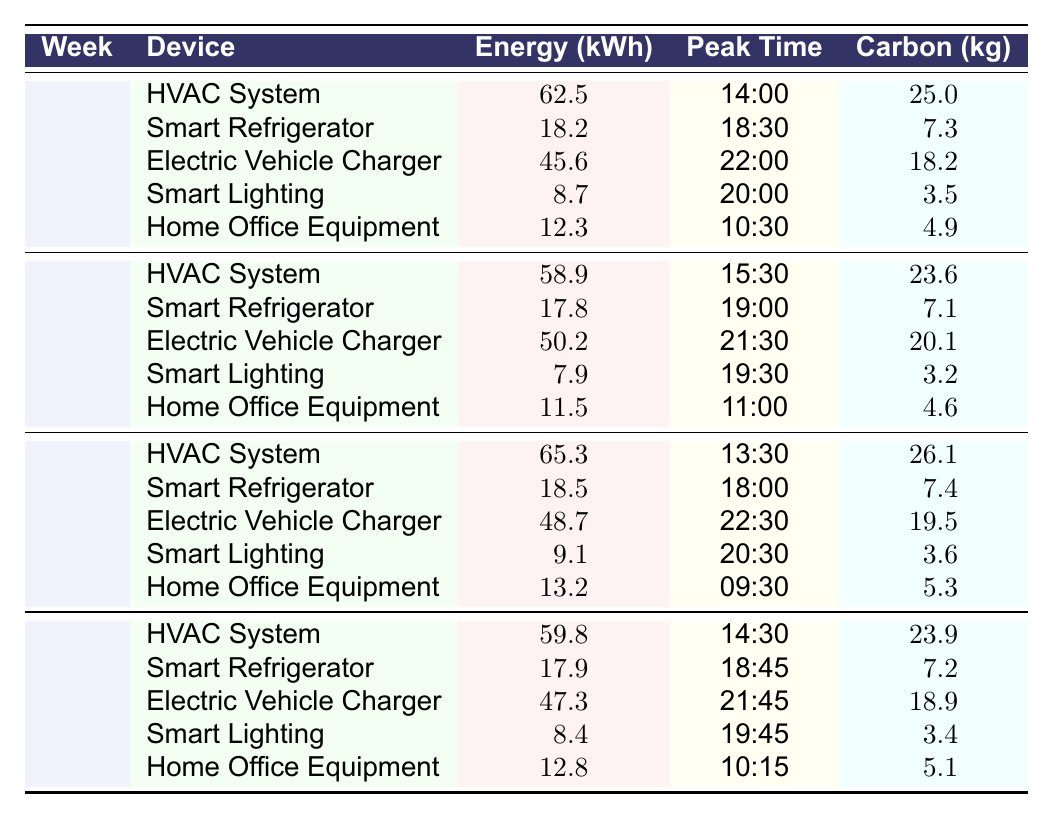What device had the highest energy consumption in Week 2? In Week 2, the devices and their energy consumption are listed. The Electric Vehicle Charger has the highest energy consumption of 50.2 kWh.
Answer: Electric Vehicle Charger What was the carbon footprint of the Smart Lighting in Week 1? The data for Week 1 shows that the Smart Lighting had a carbon footprint of 3.5 kg.
Answer: 3.5 kg What is the total energy consumption from the HVAC System across all four weeks? To find the total energy consumption for the HVAC System, add the values from each week: (62.5 + 58.9 + 65.3 + 59.8) = 246.5 kWh.
Answer: 246.5 kWh Did the energy consumption of the Smart Refrigerator increase, decrease, or stay the same from Week 1 to Week 4? In Week 1, the Smart Refrigerator used 18.2 kWh, and in Week 4 it used 17.9 kWh. This indicates a decrease in energy consumption.
Answer: Decrease What is the average carbon footprint for Home Office Equipment over the four weeks? The carbon footprints for Home Office Equipment across the weeks are: 4.9 kg (Week 1), 4.6 kg (Week 2), 5.3 kg (Week 3), and 5.1 kg (Week 4). The total is (4.9 + 4.6 + 5.3 + 5.1) = 20.9 kg, and the average is 20.9 kg / 4 = 5.225 kg.
Answer: 5.225 kg Which week had the highest peak usage time for the HVAC System? By reviewing the peak usage times for the HVAC System: Week 1 - 14:00, Week 2 - 15:30, Week 3 - 13:30, Week 4 - 14:30. The highest peak time numerically is in Week 2 at 15:30.
Answer: Week 2 How much more carbon footprint did the Electric Vehicle Charger have in Week 3 compared to Week 1? The carbon footprint for the Electric Vehicle Charger in Week 3 is 19.5 kg and in Week 1 it is 18.2 kg. The difference is 19.5 kg - 18.2 kg = 1.3 kg.
Answer: 1.3 kg What is the week with the lowest energy consumption for Smart Lighting? Reviewing the data for Smart Lighting, the energy consumptions are 8.7 kWh (Week 1), 7.9 kWh (Week 2), 9.1 kWh (Week 3), and 8.4 kWh (Week 4). Week 2 has the lowest at 7.9 kWh.
Answer: Week 2 Which device contributed most to carbon emissions in Week 3? In Week 3, the carbon emissions are as follows: HVAC System - 26.1 kg, Smart Refrigerator - 7.4 kg, Electric Vehicle Charger - 19.5 kg, Smart Lighting - 3.6 kg, Home Office Equipment - 5.3 kg. The HVAC System contributes the most at 26.1 kg.
Answer: HVAC System Was the energy consumption for the Smart Refrigerator in Week 4 lower than in Week 2? The Smart Refrigerator consumed 17.9 kWh in Week 4 and 17.8 kWh in Week 2. Thus, it is not lower, as it is equal and higher than in Week 2.
Answer: No 